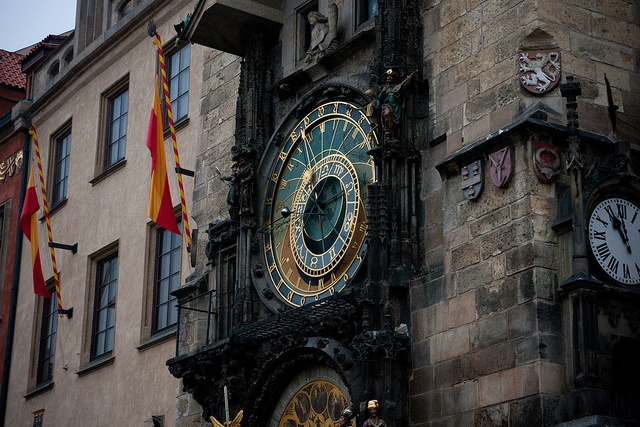Describe the objects in this image and their specific colors. I can see clock in darkgray, black, blue, gray, and tan tones, clock in darkgray, gray, and black tones, and clock in darkgray, black, and olive tones in this image. 